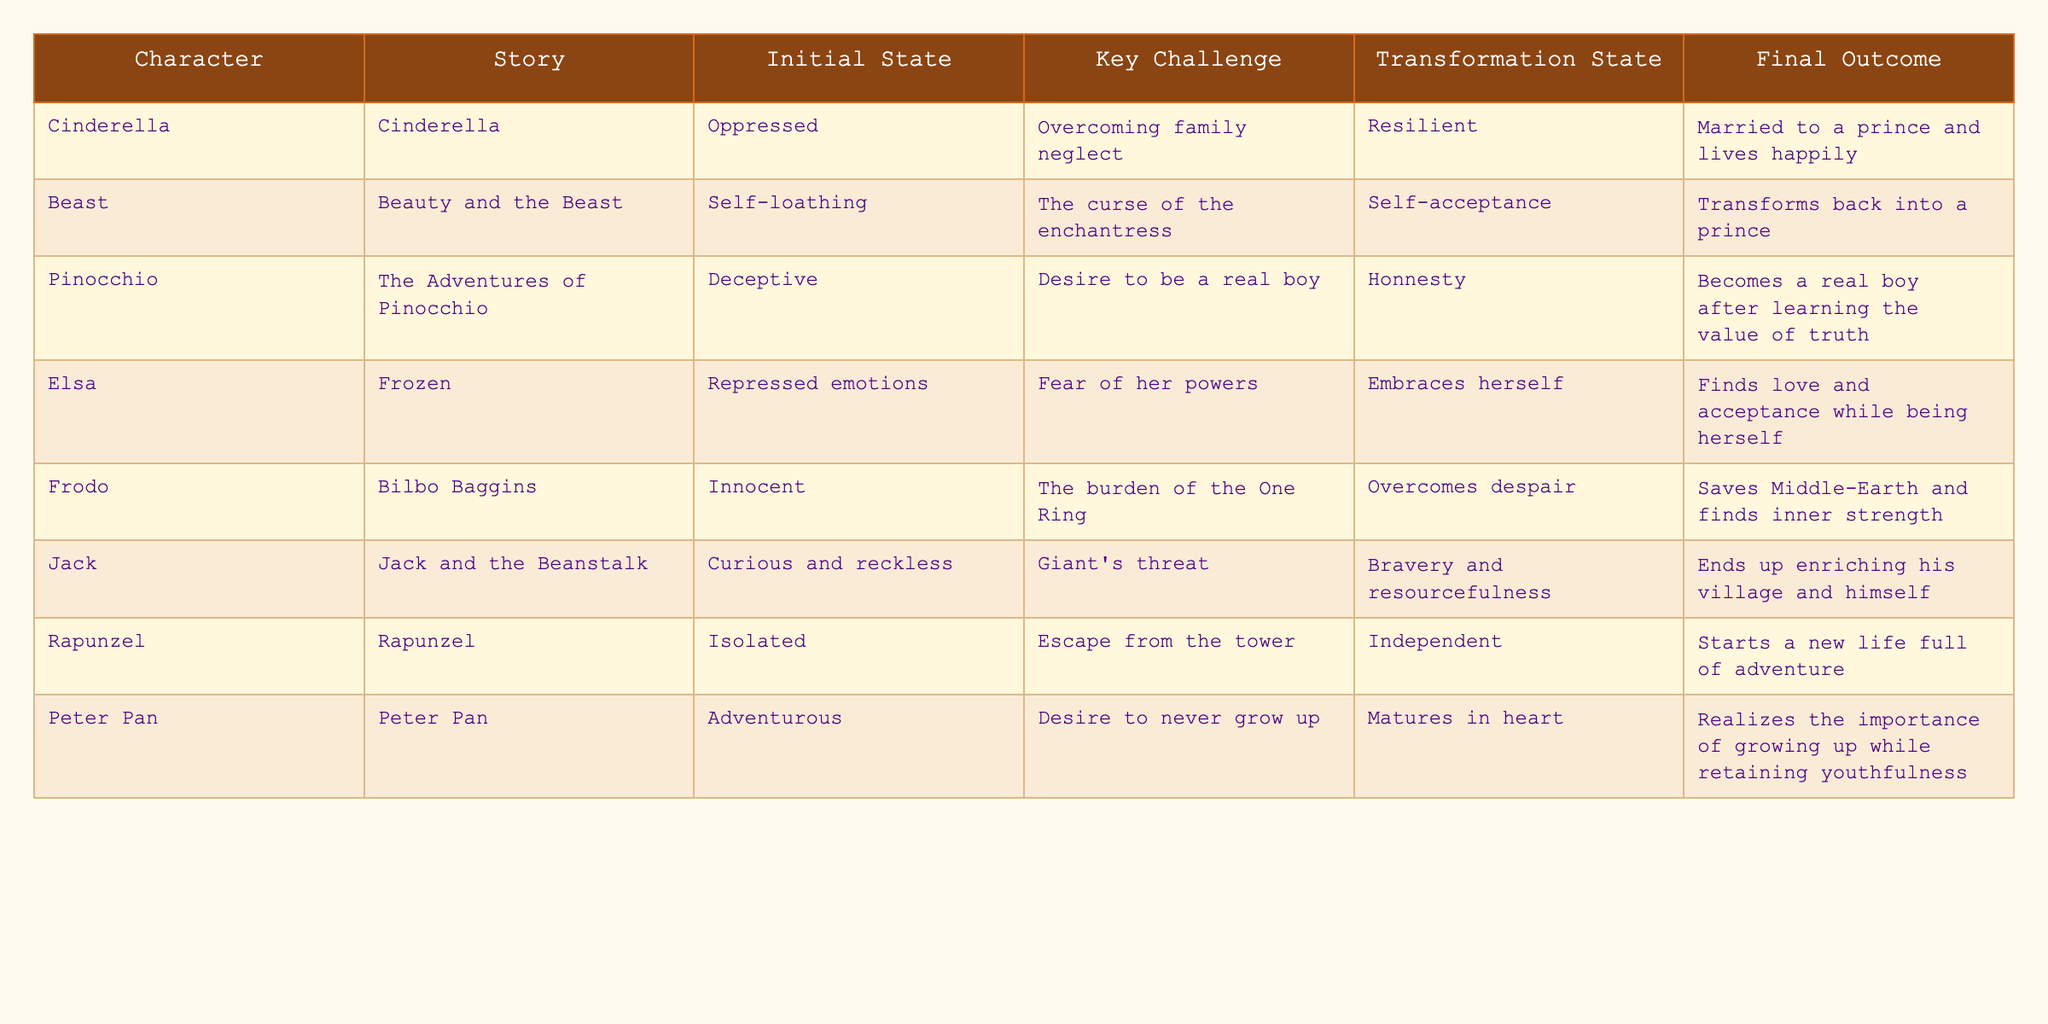What is the initial state of Cinderella? The table lists Cinderella's initial state as "Oppressed."
Answer: Oppressed What final outcome does the Beast achieve? According to the table, the Beast's final outcome is that he "Transforms back into a prince."
Answer: Transforms back into a prince How many characters experience a transformation related to self-acceptance? The table shows two characters: the Beast, with self-acceptance, and Elsa, who embraces herself. Thus, the count is 2.
Answer: 2 Which character starts in an isolated state? The table indicates that Rapunzel's initial state is "Isolated."
Answer: Isolated Is there a character who saves their world as a final outcome? Frodo's final outcome is "Saves Middle-Earth," which confirms that there is indeed a character who saves their world.
Answer: Yes What is the key challenge faced by Pinocchio? The table specifies that Pinocchio's key challenge is the "Desire to be a real boy."
Answer: Desire to be a real boy Which characters' transformation states imply they became independent? Rapunzel's transformation is described as "Independent," indicating her newfound independence.
Answer: Rapunzel Which character has both an initial state and final outcome related to innocence? Frodo has the initial state of "Innocent" and ends up saving Middle-Earth, but his transformation focuses more on overcoming despair than on innocence.
Answer: Frodo Is there a character who starts off curious and reckless? Yes, Jack from "Jack and the Beanstalk" is described as "Curious and reckless" at the beginning.
Answer: Yes What connects the key challenges of Elsa and the Beast, and how do they transform as a result? Both characters face challenges related to their self-acceptance and emotional struggles. The Beast transforms into his true self, while Elsa learns to embrace her powers.
Answer: Emotional struggles leading to self-acceptance 